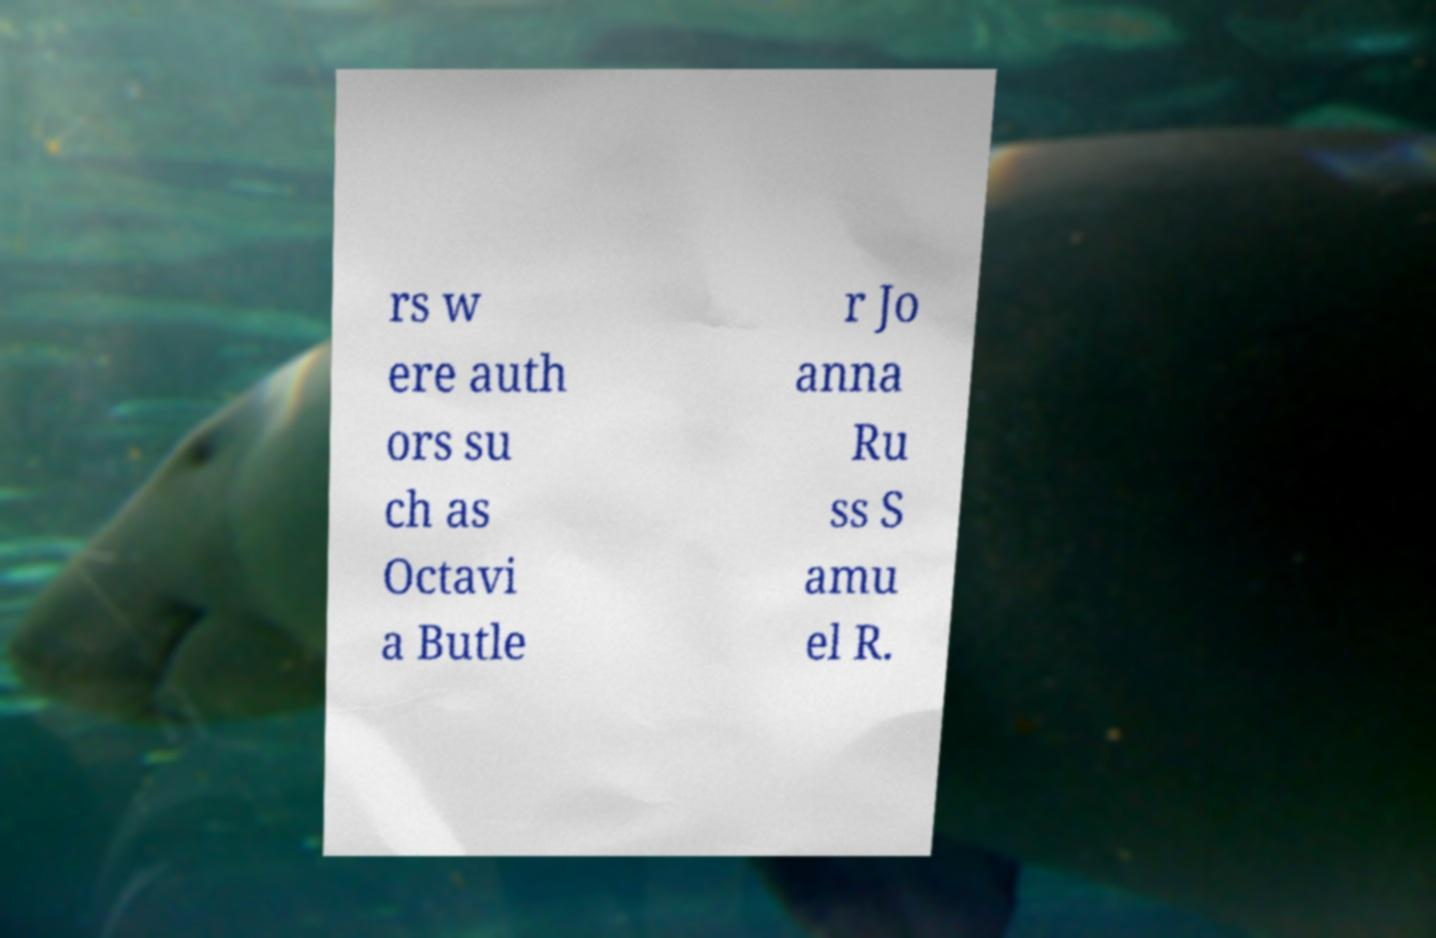What messages or text are displayed in this image? I need them in a readable, typed format. rs w ere auth ors su ch as Octavi a Butle r Jo anna Ru ss S amu el R. 